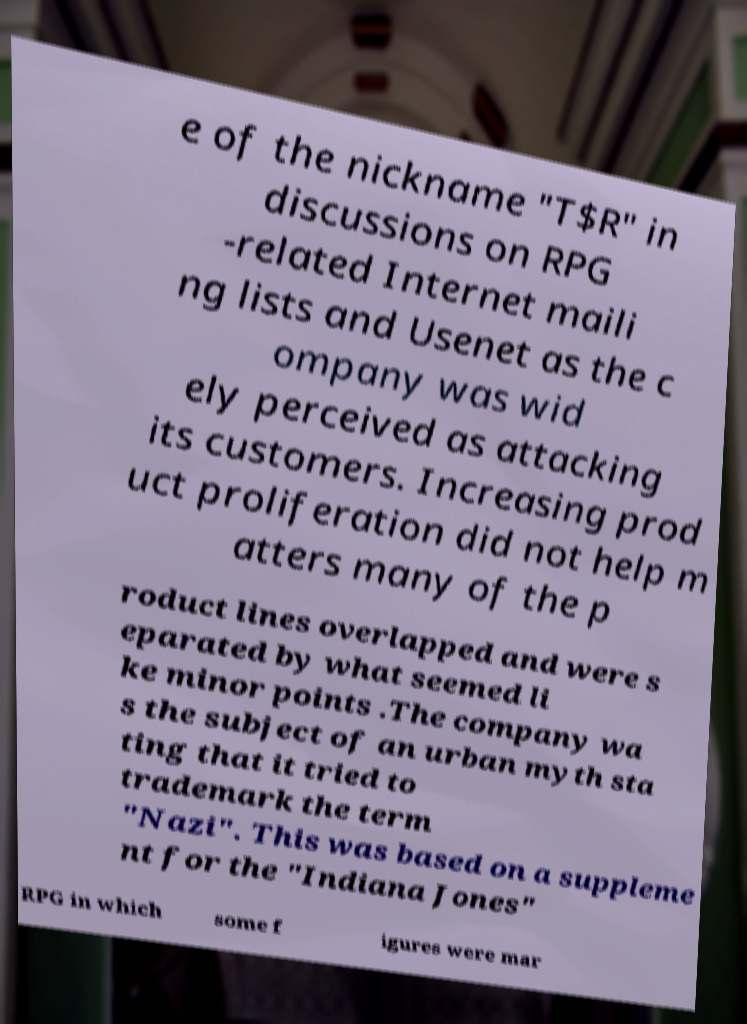Can you accurately transcribe the text from the provided image for me? e of the nickname "T$R" in discussions on RPG -related Internet maili ng lists and Usenet as the c ompany was wid ely perceived as attacking its customers. Increasing prod uct proliferation did not help m atters many of the p roduct lines overlapped and were s eparated by what seemed li ke minor points .The company wa s the subject of an urban myth sta ting that it tried to trademark the term "Nazi". This was based on a suppleme nt for the "Indiana Jones" RPG in which some f igures were mar 